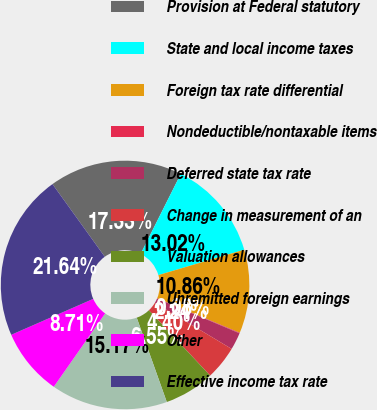Convert chart. <chart><loc_0><loc_0><loc_500><loc_500><pie_chart><fcel>Provision at Federal statutory<fcel>State and local income taxes<fcel>Foreign tax rate differential<fcel>Nondeductible/nontaxable items<fcel>Deferred state tax rate<fcel>Change in measurement of an<fcel>Valuation allowances<fcel>Unremitted foreign earnings<fcel>Other<fcel>Effective income tax rate<nl><fcel>17.33%<fcel>13.02%<fcel>10.86%<fcel>0.08%<fcel>2.24%<fcel>4.4%<fcel>6.55%<fcel>15.17%<fcel>8.71%<fcel>21.64%<nl></chart> 